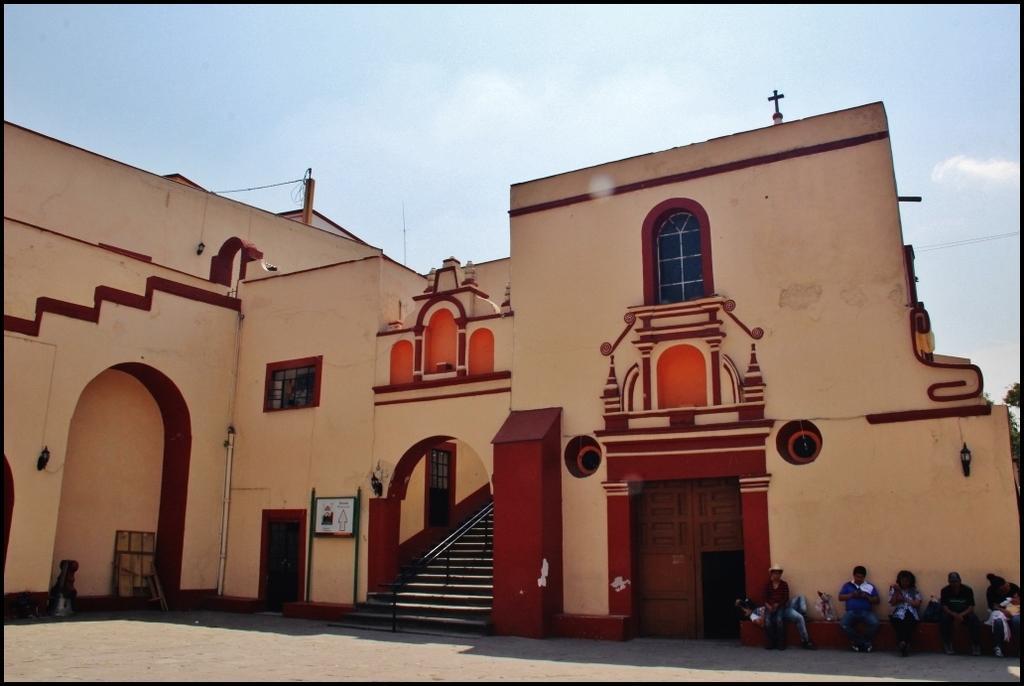Can you describe this image briefly? In the picture I can see these people are sitting near the wall and they are on the right side of the image. Here we can see the wall, stairs, the board, wires, cross symbol, windows and the sky with clouds in the background. 